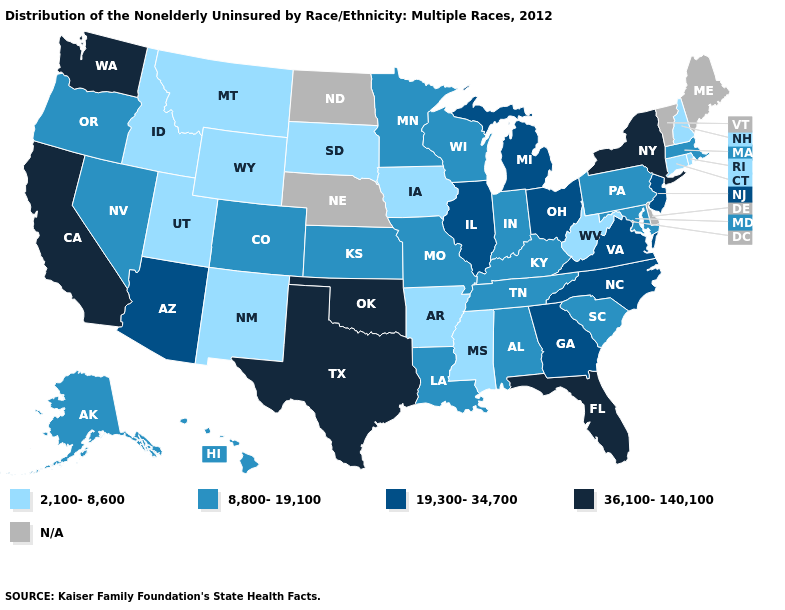Does the map have missing data?
Quick response, please. Yes. How many symbols are there in the legend?
Give a very brief answer. 5. Does the map have missing data?
Be succinct. Yes. Is the legend a continuous bar?
Keep it brief. No. What is the lowest value in states that border Wyoming?
Write a very short answer. 2,100-8,600. Which states hav the highest value in the Northeast?
Short answer required. New York. What is the highest value in states that border Virginia?
Concise answer only. 19,300-34,700. What is the value of South Dakota?
Short answer required. 2,100-8,600. Which states have the highest value in the USA?
Quick response, please. California, Florida, New York, Oklahoma, Texas, Washington. Which states have the lowest value in the Northeast?
Short answer required. Connecticut, New Hampshire, Rhode Island. What is the value of Maryland?
Short answer required. 8,800-19,100. Which states have the lowest value in the USA?
Concise answer only. Arkansas, Connecticut, Idaho, Iowa, Mississippi, Montana, New Hampshire, New Mexico, Rhode Island, South Dakota, Utah, West Virginia, Wyoming. What is the value of Georgia?
Be succinct. 19,300-34,700. What is the lowest value in states that border Tennessee?
Short answer required. 2,100-8,600. 